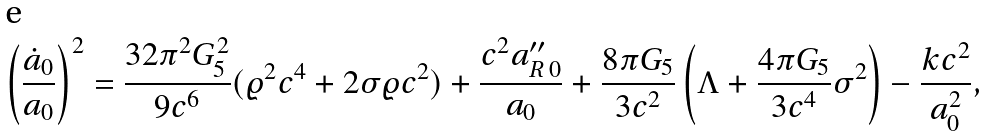Convert formula to latex. <formula><loc_0><loc_0><loc_500><loc_500>\left ( { \frac { \dot { a } _ { 0 } } { a _ { 0 } } } \right ) ^ { 2 } = { \frac { 3 2 \pi ^ { 2 } G _ { 5 } ^ { 2 } } { 9 c ^ { 6 } } } ( \varrho ^ { 2 } c ^ { 4 } + 2 \sigma \varrho c ^ { 2 } ) + { \frac { c ^ { 2 } a _ { R \, 0 } ^ { \prime \prime } } { a _ { 0 } } } + { \frac { 8 \pi G _ { 5 } } { 3 c ^ { 2 } } } \left ( \Lambda + { \frac { 4 \pi G _ { 5 } } { 3 c ^ { 4 } } } \sigma ^ { 2 } \right ) - { \frac { k c ^ { 2 } } { a _ { 0 } ^ { 2 } } } ,</formula> 